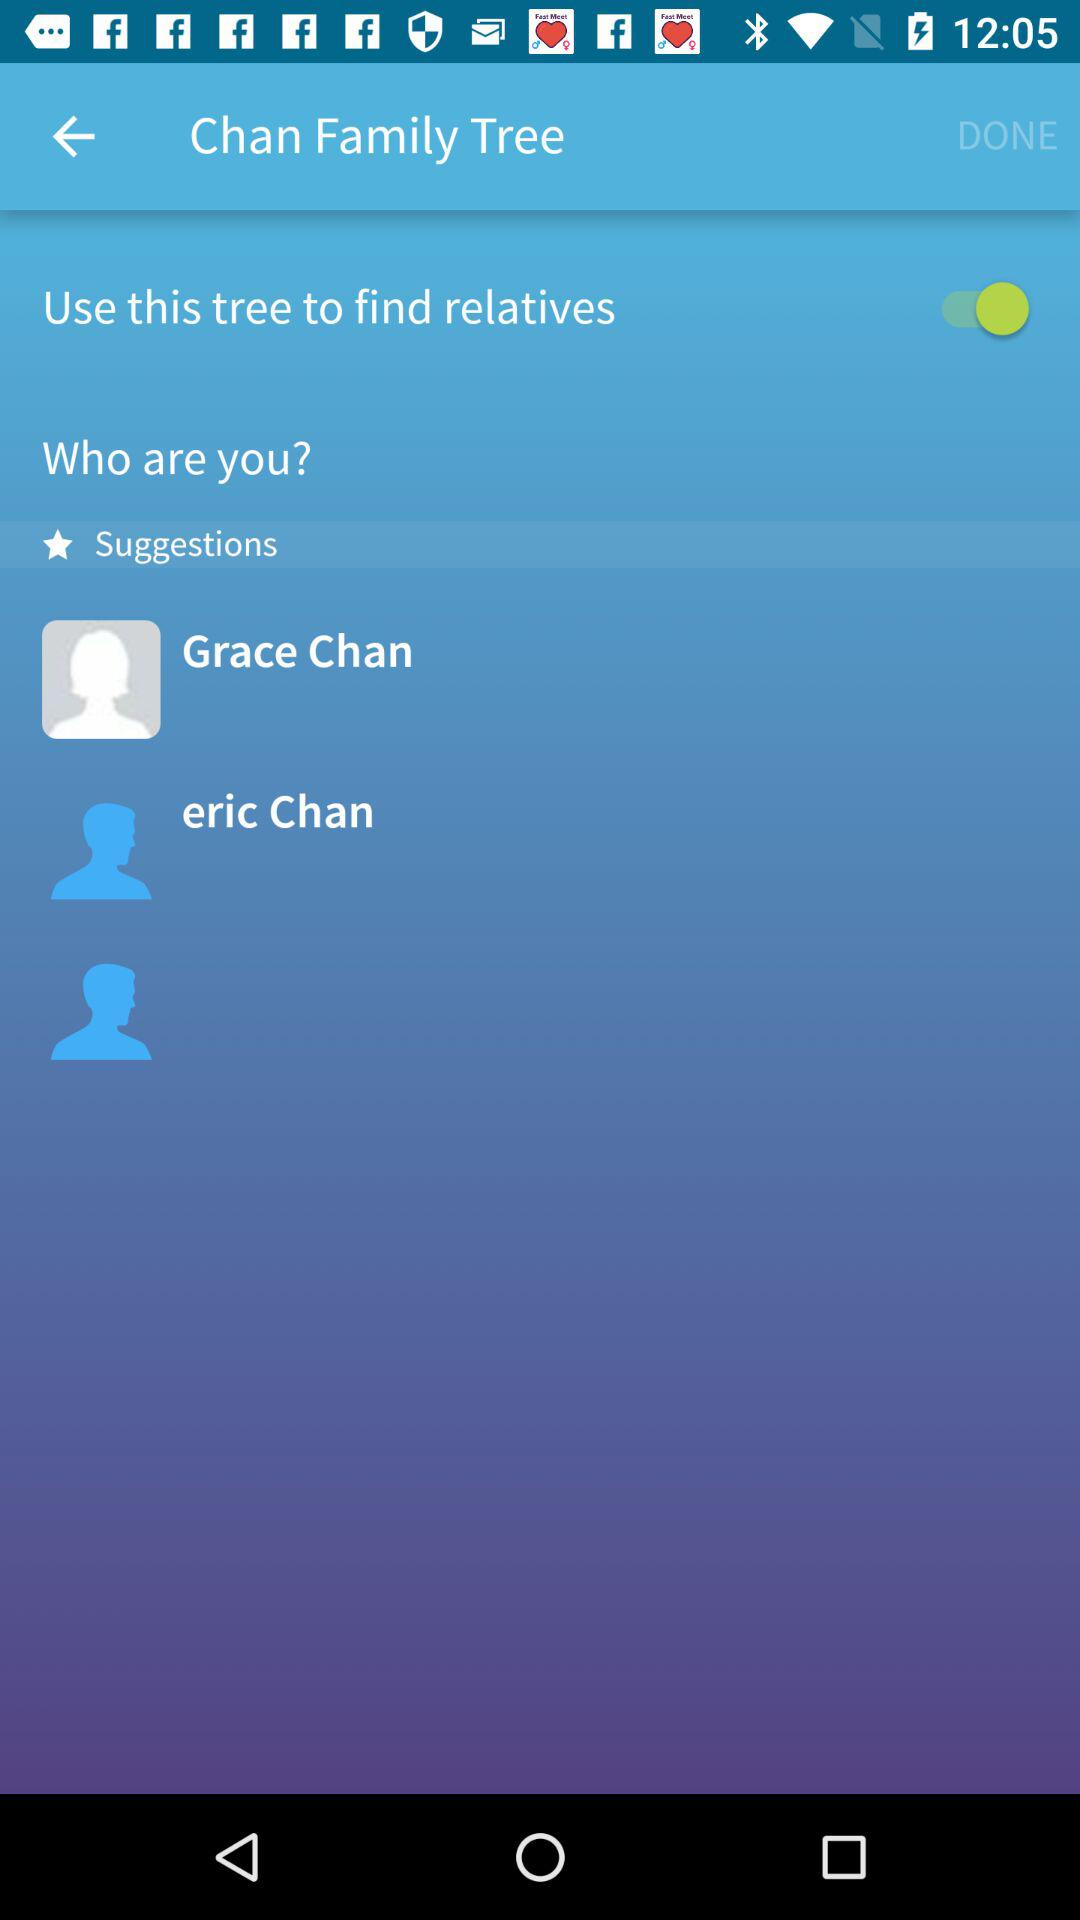Is "Use this tree to find relatives" on or off? "Use this tree to find relatives" is on. 